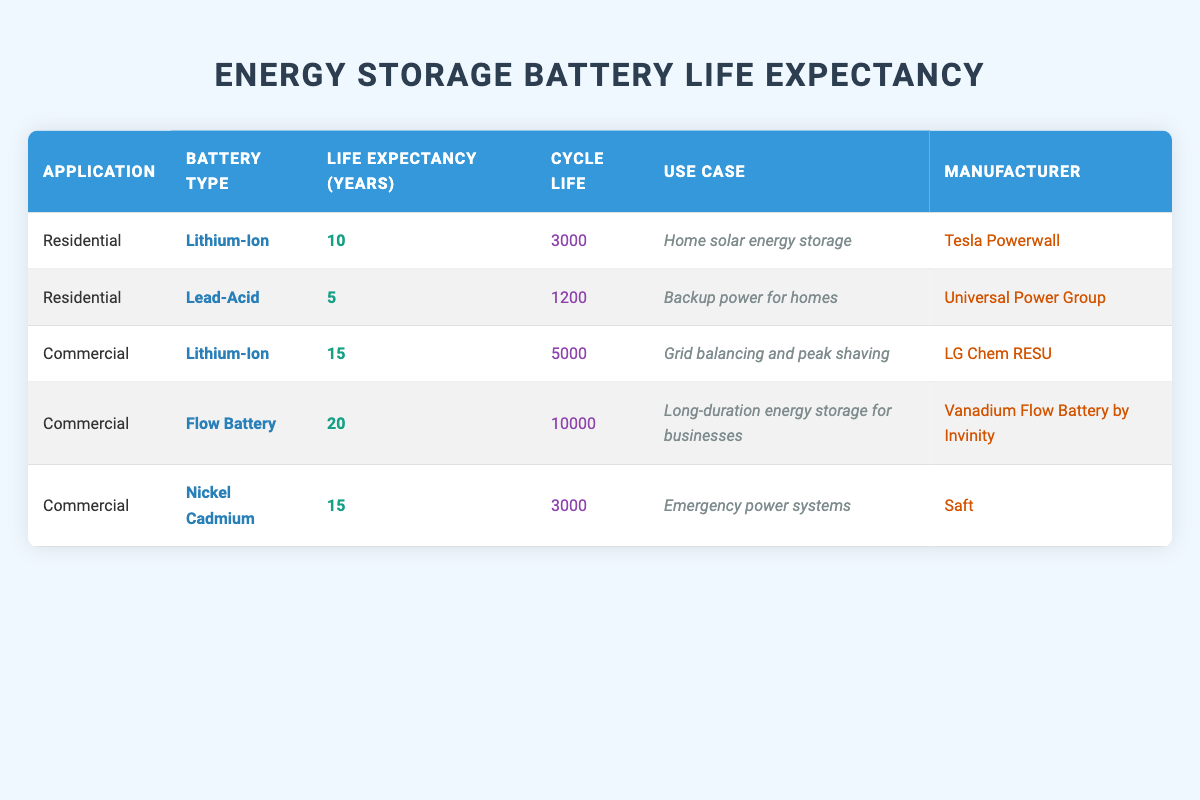What is the average life expectancy of residential energy storage batteries? There are two types of residential batteries listed: Lithium-Ion with an average life expectancy of 10 years and Lead-Acid with an average life expectancy of 5 years. To calculate the average, we sum these values (10 + 5 = 15) and divide by the number of types (2), which gives 15/2 = 7.5 years.
Answer: 7.5 years Is the life expectancy of commercial Lithium-Ion batteries greater than the life expectancy of residential Lead-Acid batteries? The life expectancy of commercial Lithium-Ion batteries is 15 years, while the life expectancy of residential Lead-Acid batteries is 5 years. Since 15 is greater than 5, the statement is true.
Answer: Yes Which commercial battery type has the longest life expectancy? The table lists commercial battery types with life expectancies: Lithium-Ion (15 years), Flow Battery (20 years), and Nickel Cadmium (15 years). The Flow Battery has the longest life expectancy of 20 years.
Answer: Flow Battery What is the total cycle life of all residential energy storage batteries? The cycle life for residential batteries includes Lithium-Ion with 3000 cycles and Lead-Acid with 1200 cycles. Summing these values gives us 3000 + 1200 = 4200 cycles.
Answer: 4200 cycles Do all commercial energy storage batteries have a life expectancy of more than 10 years? The life expectancies for commercial batteries are Lithium-Ion (15 years), Flow Battery (20 years), and Nickel Cadmium (15 years). Since all are greater than 10, the statement is true.
Answer: Yes What is the difference in average life expectancy between the best residential and the best commercial battery types? The best residential battery type is Lithium-Ion at 10 years, while the best commercial battery type (Flow Battery) is at 20 years. The difference in their life expectancy is 20 - 10 = 10 years.
Answer: 10 years How many different manufacturers are mentioned in the table? The table lists four manufacturers: Tesla Powerwall, Universal Power Group, LG Chem RESU, and Vanadium Flow Battery by Invinity, as well as Saft. This totals to five unique manufacturers.
Answer: 5 What is the average cycle life of commercial energy storage batteries? The cycle lives for commercial batteries are: Lithium-Ion (5000), Flow Battery (10000), and Nickel Cadmium (3000). To find the average, we sum these values (5000 + 10000 + 3000 = 18000) and divide by the number of types (3), resulting in 18000/3 = 6000 cycles.
Answer: 6000 cycles Is Lead-Acid the only type of residential energy storage battery listed? The table indicates there are two types of residential batteries: Lithium-Ion and Lead-Acid. Therefore, Lead-Acid is not the only type listed.
Answer: No 